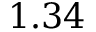<formula> <loc_0><loc_0><loc_500><loc_500>1 . 3 4</formula> 